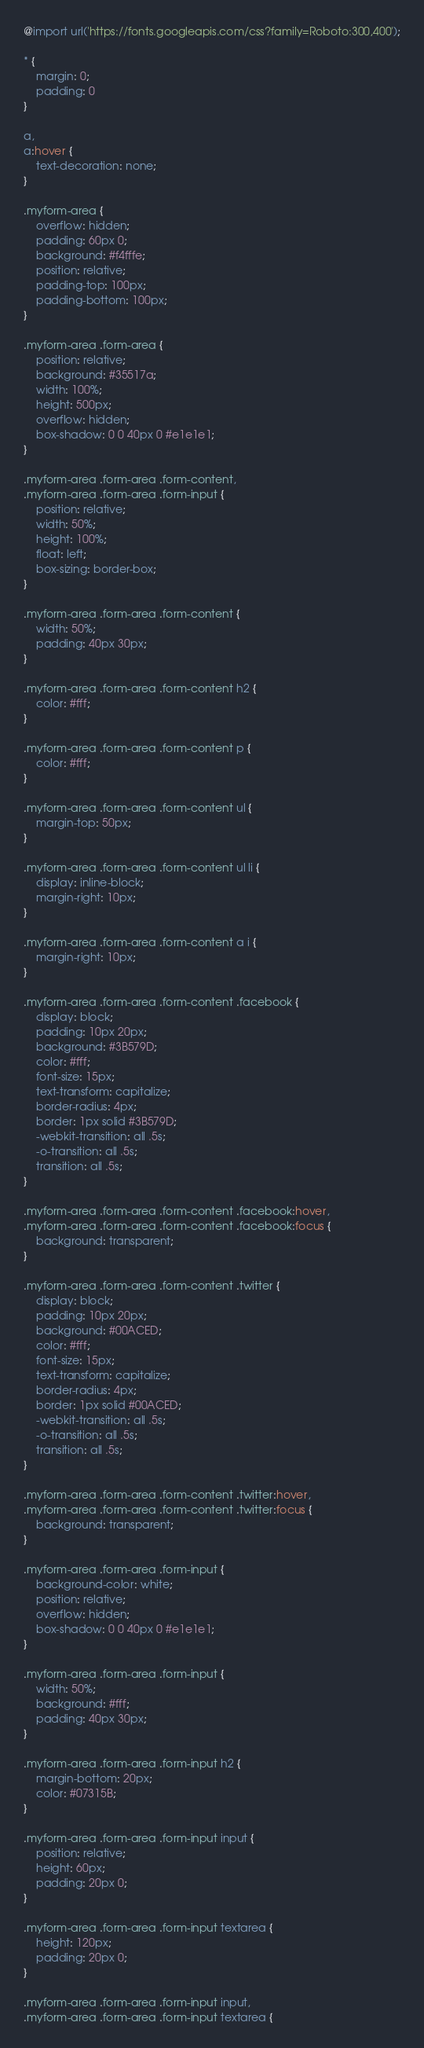<code> <loc_0><loc_0><loc_500><loc_500><_CSS_>@import url('https://fonts.googleapis.com/css?family=Roboto:300,400');

* {
    margin: 0;
    padding: 0
}

a,
a:hover {
    text-decoration: none;
}

.myform-area {
    overflow: hidden;
    padding: 60px 0;
    background: #f4fffe;
    position: relative;
    padding-top: 100px;
    padding-bottom: 100px;
}

.myform-area .form-area {
    position: relative;
    background: #35517a;
    width: 100%;
    height: 500px;
    overflow: hidden;
    box-shadow: 0 0 40px 0 #e1e1e1;
}

.myform-area .form-area .form-content,
.myform-area .form-area .form-input {
    position: relative;
    width: 50%;
    height: 100%;
    float: left;
    box-sizing: border-box;
}

.myform-area .form-area .form-content {
    width: 50%;
    padding: 40px 30px;
}

.myform-area .form-area .form-content h2 {
    color: #fff;
}

.myform-area .form-area .form-content p {
    color: #fff;
}

.myform-area .form-area .form-content ul {
    margin-top: 50px;
}

.myform-area .form-area .form-content ul li {
    display: inline-block;
    margin-right: 10px;
}

.myform-area .form-area .form-content a i {
    margin-right: 10px;
}

.myform-area .form-area .form-content .facebook {
    display: block;
    padding: 10px 20px;
    background: #3B579D;
    color: #fff;
    font-size: 15px;
    text-transform: capitalize;
    border-radius: 4px;
    border: 1px solid #3B579D;
    -webkit-transition: all .5s;
    -o-transition: all .5s;
    transition: all .5s;
}

.myform-area .form-area .form-content .facebook:hover,
.myform-area .form-area .form-content .facebook:focus {
    background: transparent;
}

.myform-area .form-area .form-content .twitter {
    display: block;
    padding: 10px 20px;
    background: #00ACED;
    color: #fff;
    font-size: 15px;
    text-transform: capitalize;
    border-radius: 4px;
    border: 1px solid #00ACED;
    -webkit-transition: all .5s;
    -o-transition: all .5s;
    transition: all .5s;
}

.myform-area .form-area .form-content .twitter:hover,
.myform-area .form-area .form-content .twitter:focus {
    background: transparent;
}

.myform-area .form-area .form-input {
    background-color: white;
    position: relative;
    overflow: hidden;
    box-shadow: 0 0 40px 0 #e1e1e1;
}

.myform-area .form-area .form-input {
    width: 50%;
    background: #fff;
    padding: 40px 30px;
}

.myform-area .form-area .form-input h2 {
    margin-bottom: 20px;
    color: #07315B;
}

.myform-area .form-area .form-input input {
    position: relative;
    height: 60px;
    padding: 20px 0;
}

.myform-area .form-area .form-input textarea {
    height: 120px;
    padding: 20px 0;
}

.myform-area .form-area .form-input input,
.myform-area .form-area .form-input textarea {</code> 